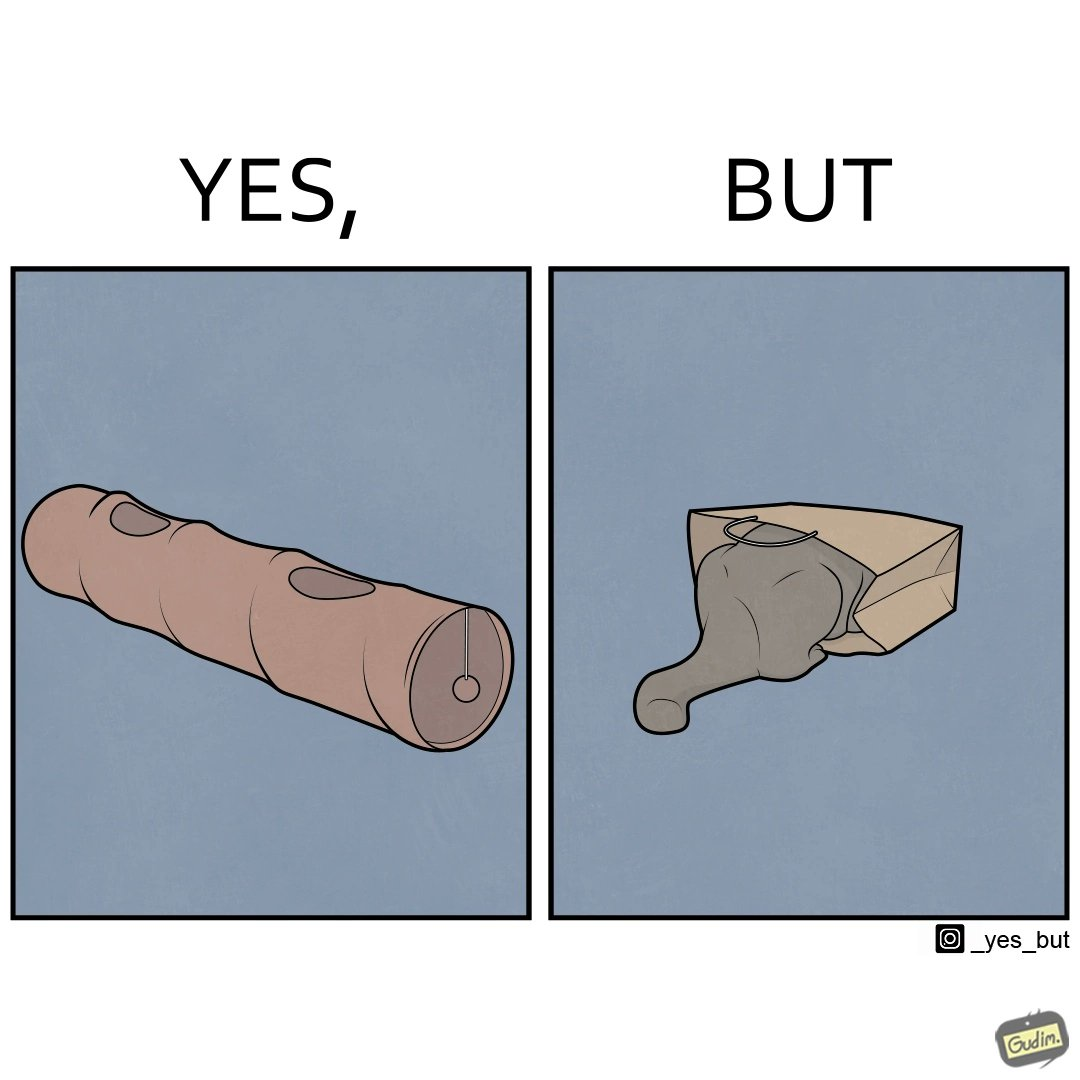What does this image depict? The image is funny, because even when there is a dedicated thing for the animal to play with it still is hiding itself in the paper bag 